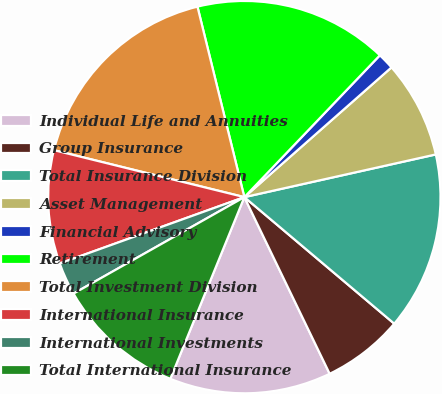<chart> <loc_0><loc_0><loc_500><loc_500><pie_chart><fcel>Individual Life and Annuities<fcel>Group Insurance<fcel>Total Insurance Division<fcel>Asset Management<fcel>Financial Advisory<fcel>Retirement<fcel>Total Investment Division<fcel>International Insurance<fcel>International Investments<fcel>Total International Insurance<nl><fcel>13.32%<fcel>6.68%<fcel>14.65%<fcel>8.01%<fcel>1.36%<fcel>15.98%<fcel>17.31%<fcel>9.34%<fcel>2.69%<fcel>10.66%<nl></chart> 